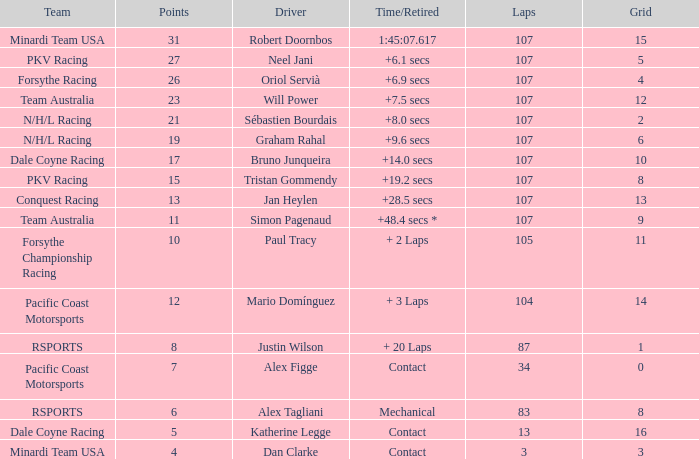What is the highest number of points scored by minardi team usa in more than 13 laps? 31.0. 